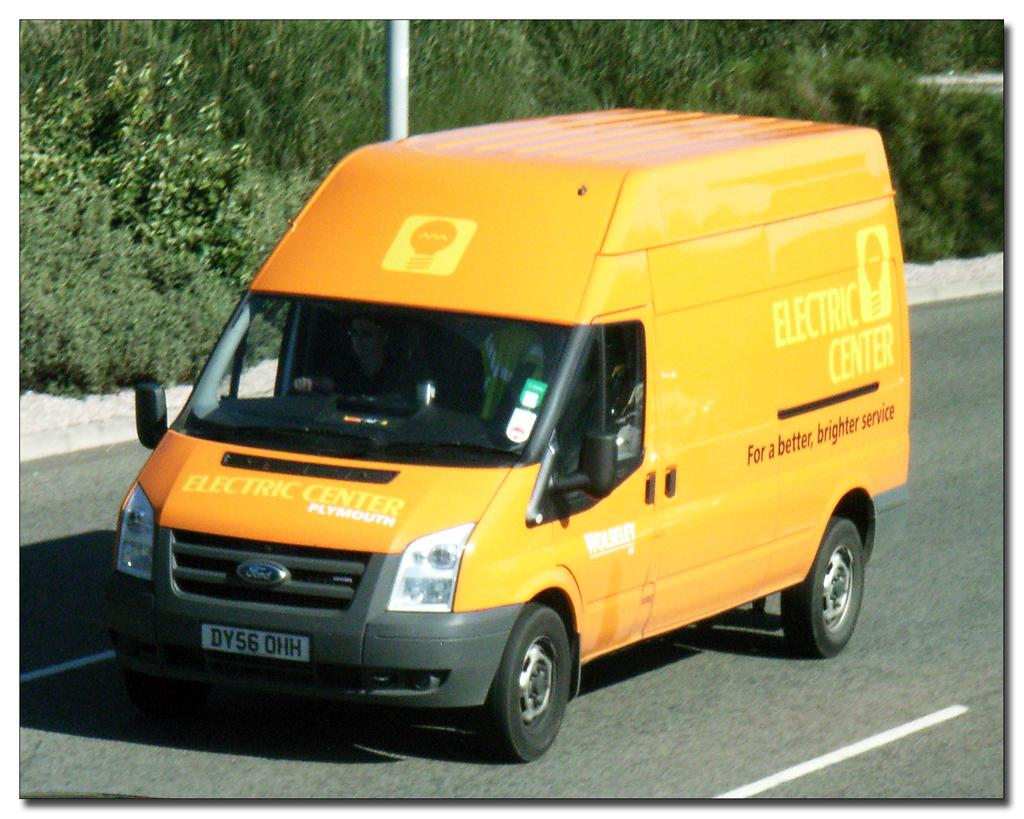<image>
Present a compact description of the photo's key features. the word electric that is on a yellow van 